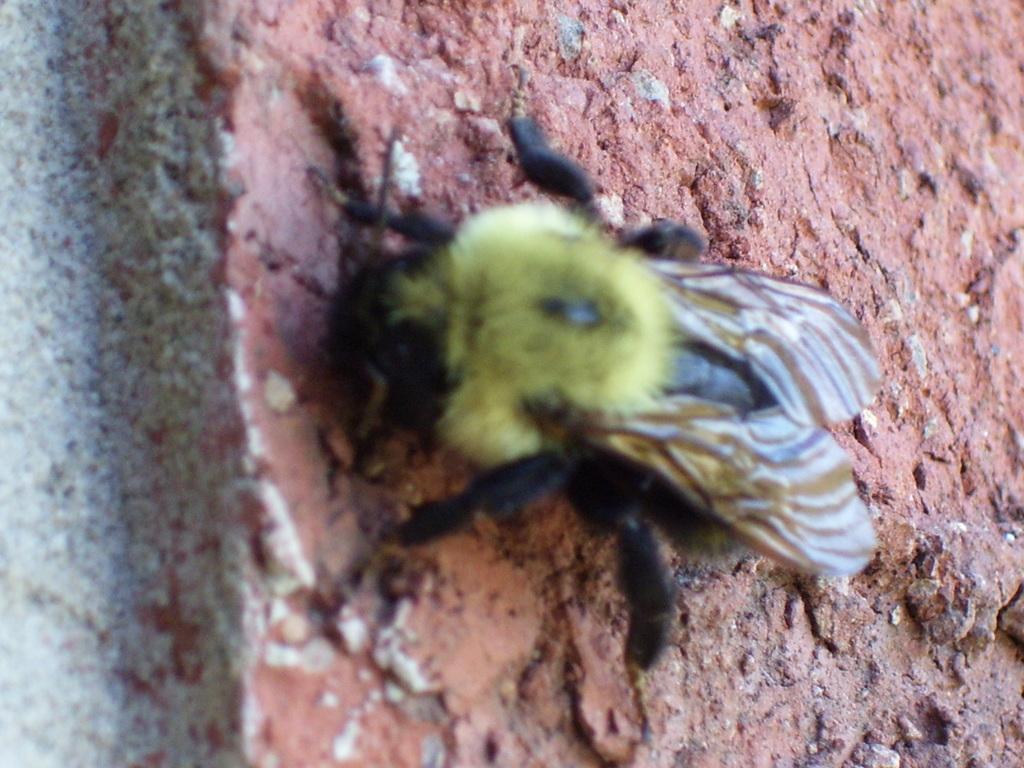Please provide a concise description of this image. In this image we can see an insect on the ground where we can see the stones. 